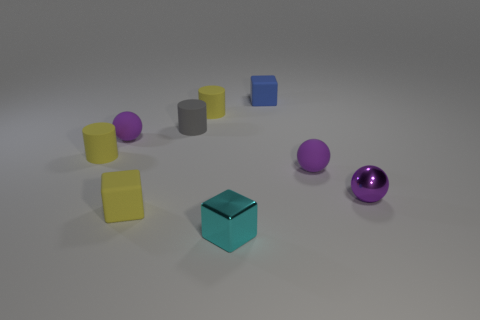Are there any other things that are the same material as the small blue block? Yes, the small blue block appears to be made of plastic, and several other items in the image such as the yellow cylinders, gray cube, and the purple sphere have the same plastic appearance. 